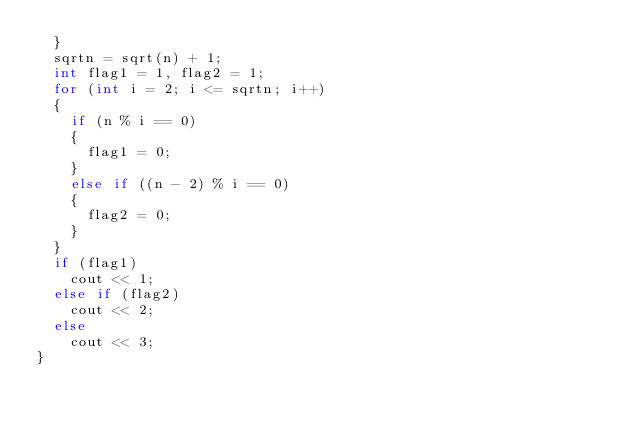Convert code to text. <code><loc_0><loc_0><loc_500><loc_500><_C++_>	}
	sqrtn = sqrt(n) + 1;
	int flag1 = 1, flag2 = 1;
	for (int i = 2; i <= sqrtn; i++)
	{
		if (n % i == 0)
		{
			flag1 = 0;
		}
		else if ((n - 2) % i == 0)
		{
			flag2 = 0;
		}
	}
	if (flag1)
		cout << 1;
	else if (flag2)
		cout << 2;
	else
		cout << 3;
}
</code> 